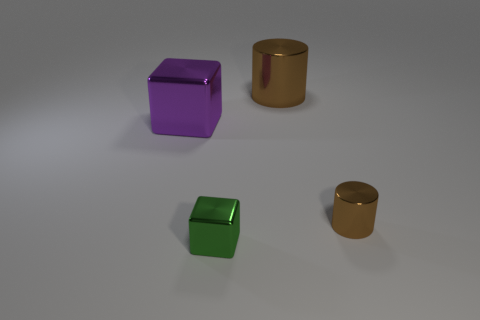There is a green shiny thing; does it have the same shape as the large metallic object that is on the left side of the tiny green block?
Your response must be concise. Yes. Are there more big brown things on the right side of the big brown cylinder than tiny brown objects?
Make the answer very short. No. Are there fewer small green objects that are on the left side of the tiny brown thing than large cylinders?
Make the answer very short. No. How many things are the same color as the tiny cylinder?
Ensure brevity in your answer.  1. What is the thing that is behind the small brown cylinder and in front of the large brown shiny object made of?
Your answer should be very brief. Metal. There is a cylinder behind the big purple block; is it the same color as the tiny object left of the small metal cylinder?
Make the answer very short. No. What number of brown things are tiny cylinders or metallic cubes?
Provide a succinct answer. 1. Is the number of large cylinders that are on the right side of the small green block less than the number of purple metallic cubes in front of the large purple cube?
Provide a succinct answer. No. Is there a yellow cylinder of the same size as the green cube?
Give a very brief answer. No. Does the block in front of the purple block have the same size as the large brown metal object?
Provide a short and direct response. No. 